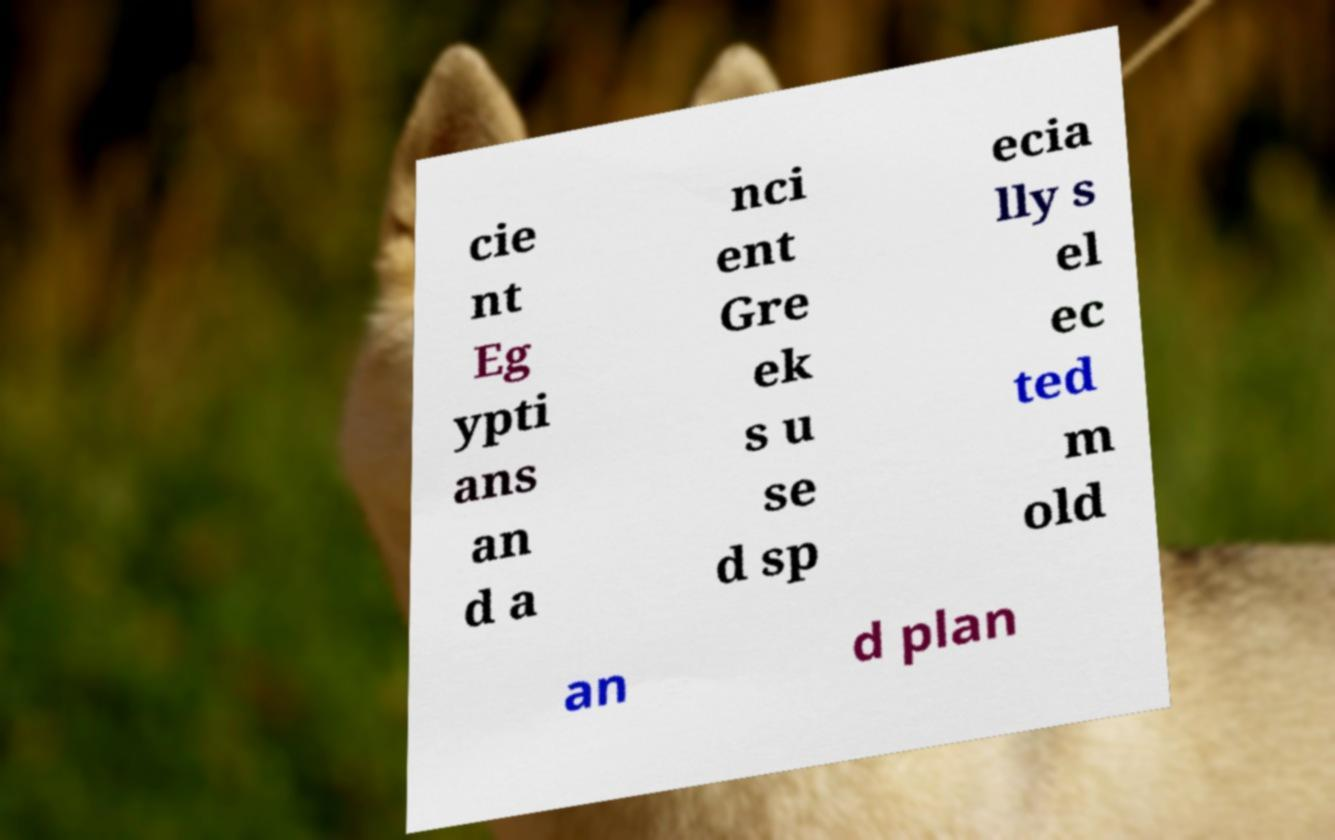Can you accurately transcribe the text from the provided image for me? cie nt Eg ypti ans an d a nci ent Gre ek s u se d sp ecia lly s el ec ted m old an d plan 